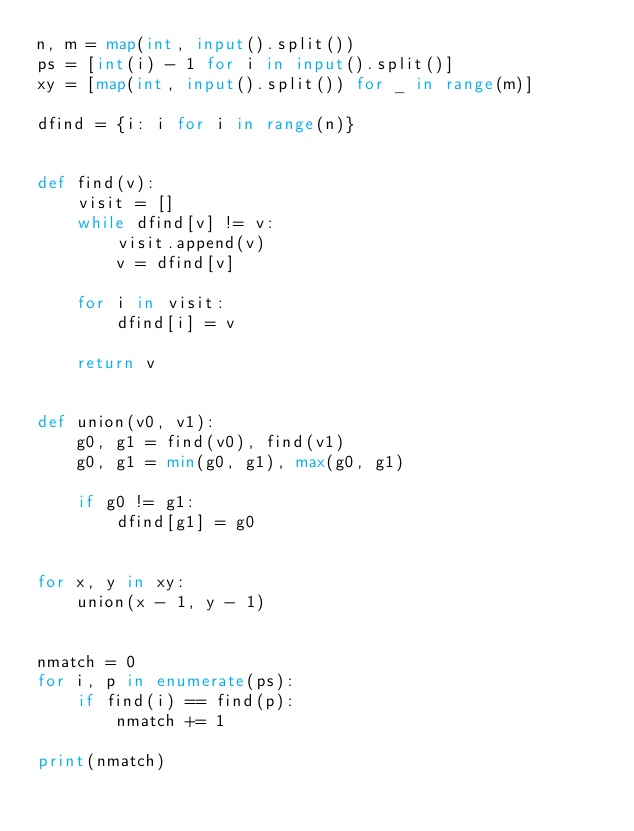<code> <loc_0><loc_0><loc_500><loc_500><_Python_>n, m = map(int, input().split())
ps = [int(i) - 1 for i in input().split()]
xy = [map(int, input().split()) for _ in range(m)]

dfind = {i: i for i in range(n)}


def find(v):
    visit = []
    while dfind[v] != v:
        visit.append(v)
        v = dfind[v]

    for i in visit:
        dfind[i] = v

    return v


def union(v0, v1):
    g0, g1 = find(v0), find(v1)
    g0, g1 = min(g0, g1), max(g0, g1)

    if g0 != g1:
        dfind[g1] = g0


for x, y in xy:
    union(x - 1, y - 1)


nmatch = 0
for i, p in enumerate(ps):
    if find(i) == find(p):
        nmatch += 1

print(nmatch)
</code> 